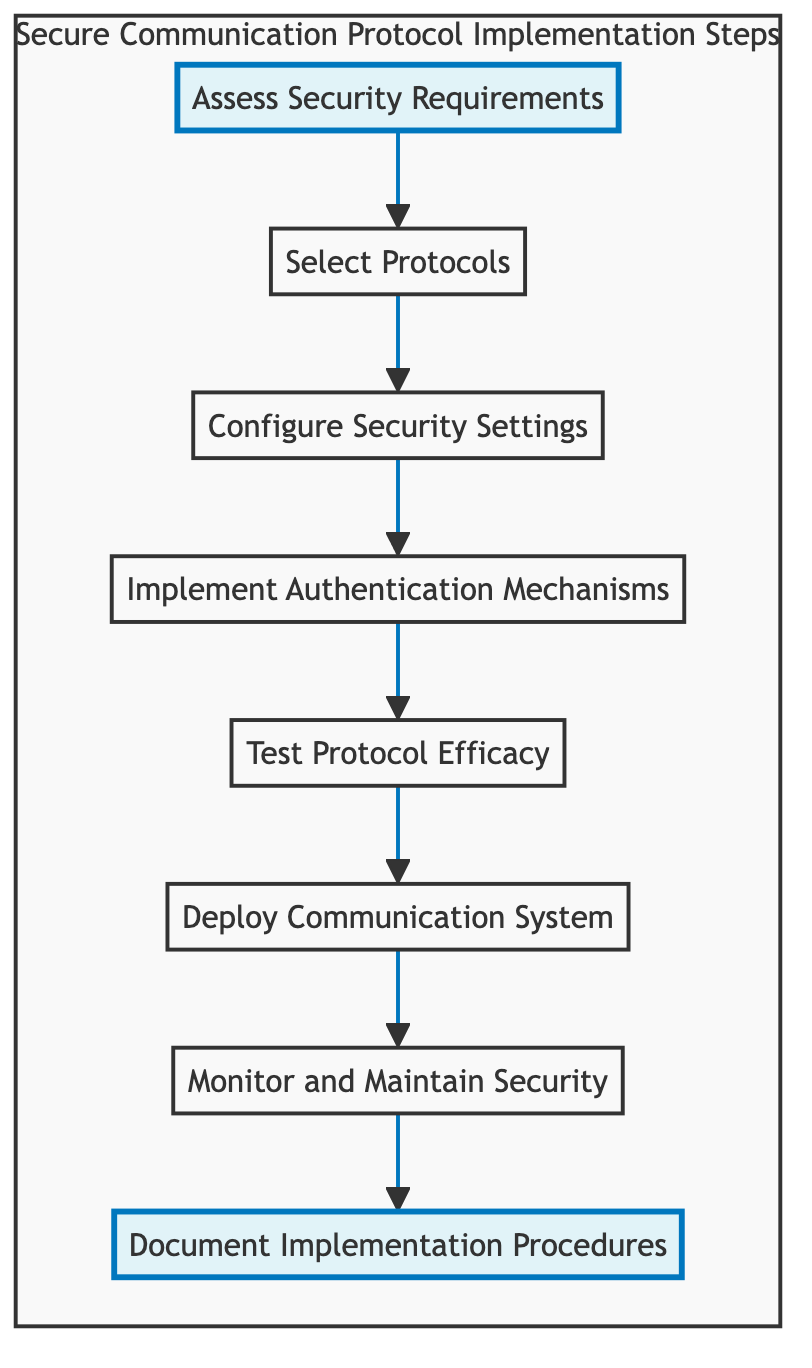What is the first step in the implementation process? The diagram indicates that the first step is "Assess Security Requirements," which is at the top of the flowchart and serves as the starting point for the process.
Answer: Assess Security Requirements How many steps are there in total? The flowchart consists of eight distinct steps, as counted from the top to bottom nodes in the diagram.
Answer: 8 Which step directly follows "Configure Security Settings"? In the flowchart, "Implement Authentication Mechanisms" is the step that comes directly after "Configure Security Settings," showing a sequential relationship between them.
Answer: Implement Authentication Mechanisms What is the last step of the process? The last step in the implementation process is "Document Implementation Procedures," which is at the bottom of the flowchart.
Answer: Document Implementation Procedures What are the two highlighted steps in the diagram? The highlighted steps in the diagram are "Assess Security Requirements" and "Document Implementation Procedures," indicating their importance in the overall process flow.
Answer: Assess Security Requirements, Document Implementation Procedures Which step is connected to "Test Protocol Efficacy"? The step connected to "Test Protocol Efficacy" is "Implement Authentication Mechanisms," demonstrating the order in which these specific actions must be taken in the protocol implementation process.
Answer: Implement Authentication Mechanisms If the security requirements are assessed, which step immediately follows? After "Assess Security Requirements," the next immediate step, according to the diagram, is "Select Protocols." This shows the direct progression from assessment to selection in the implementation sequence.
Answer: Select Protocols What is the common objective of the steps following "Deploy Communication System"? The steps following "Deploy Communication System" are "Monitor and Maintain Security" and "Document Implementation Procedures," both aimed at ensuring ongoing security and proper documentation.
Answer: Monitor and Maintain Security, Document Implementation Procedures 